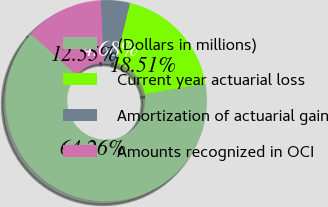Convert chart. <chart><loc_0><loc_0><loc_500><loc_500><pie_chart><fcel>(Dollars in millions)<fcel>Current year actuarial loss<fcel>Amortization of actuarial gain<fcel>Amounts recognized in OCI<nl><fcel>64.27%<fcel>18.51%<fcel>4.68%<fcel>12.55%<nl></chart> 